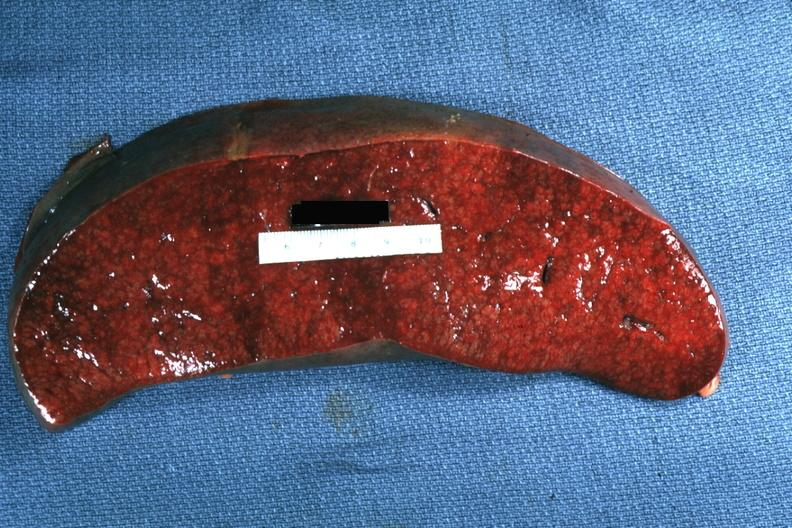s hematologic present?
Answer the question using a single word or phrase. Yes 